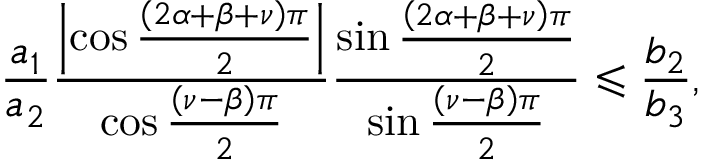Convert formula to latex. <formula><loc_0><loc_0><loc_500><loc_500>\frac { a _ { 1 } } { a _ { 2 } } \frac { \left | \cos \frac { \left ( 2 \alpha + \beta + \nu \right ) \pi } { 2 } \right | } { \cos \frac { \left ( \nu - \beta \right ) \pi } { 2 } } \frac { \sin \frac { \left ( 2 \alpha + \beta + \nu \right ) \pi } { 2 } } { \sin \frac { \left ( \nu - \beta \right ) \pi } { 2 } } \leqslant \frac { b _ { 2 } } { b _ { 3 } } ,</formula> 